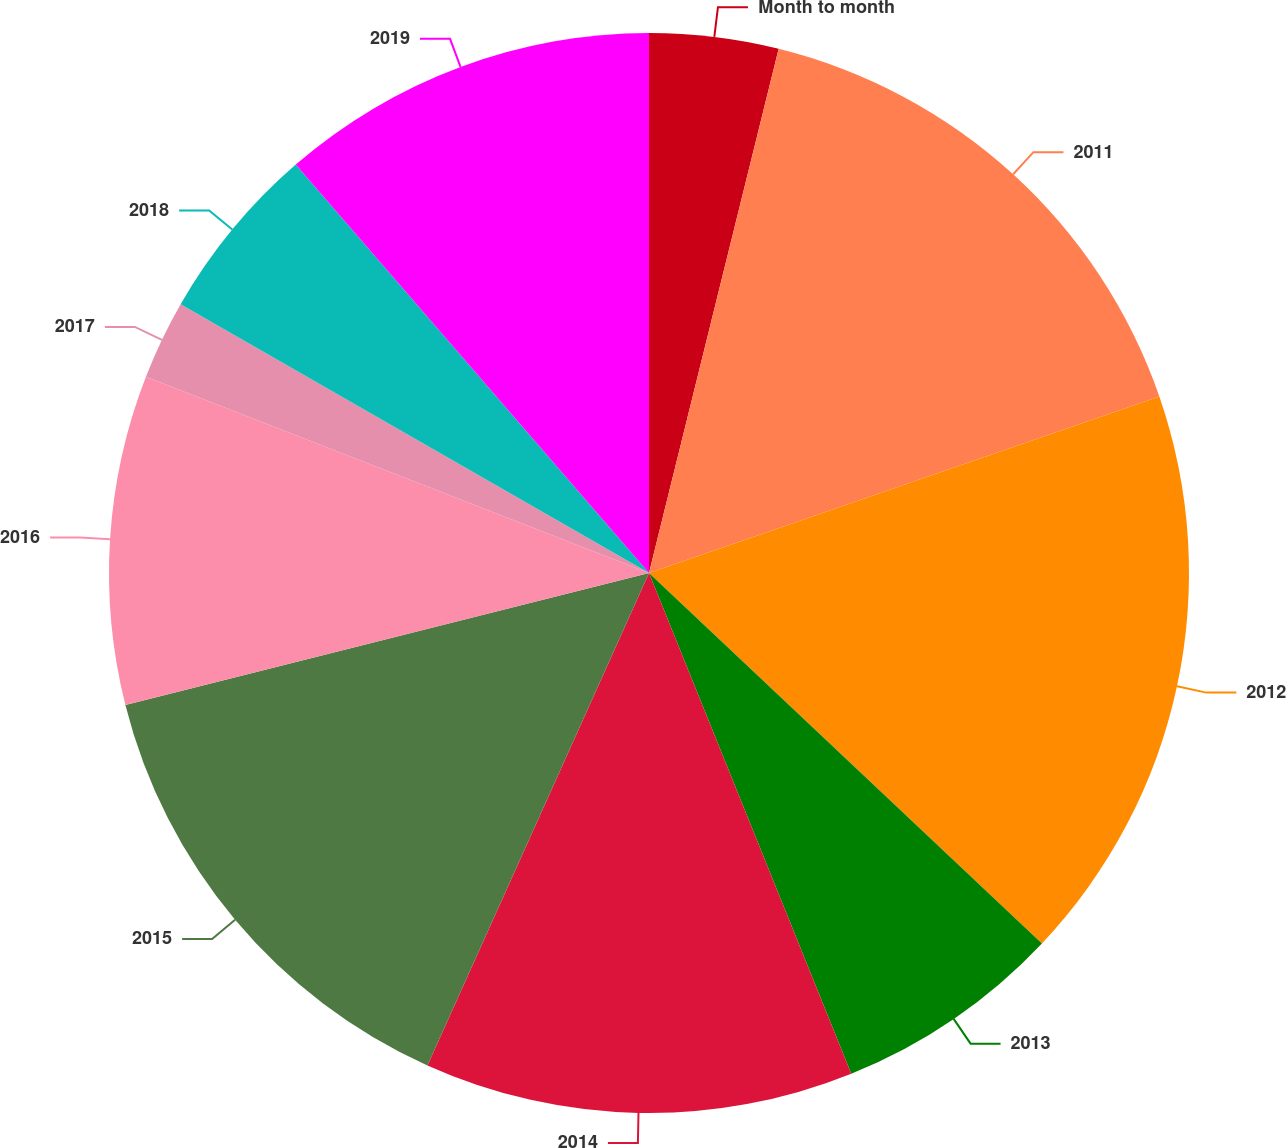<chart> <loc_0><loc_0><loc_500><loc_500><pie_chart><fcel>Month to month<fcel>2011<fcel>2012<fcel>2013<fcel>2014<fcel>2015<fcel>2016<fcel>2017<fcel>2018<fcel>2019<nl><fcel>3.86%<fcel>15.84%<fcel>17.33%<fcel>6.86%<fcel>12.84%<fcel>14.34%<fcel>9.85%<fcel>2.37%<fcel>5.36%<fcel>11.35%<nl></chart> 